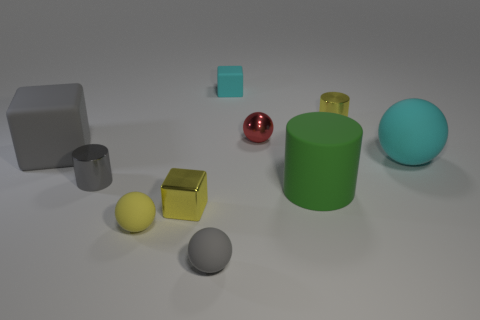The tiny yellow object that is right of the rubber cube behind the tiny metal object that is right of the small metallic ball is what shape?
Your answer should be very brief. Cylinder. There is a cyan thing that is on the left side of the large cyan matte object; is its shape the same as the small shiny object behind the red metal object?
Make the answer very short. No. What number of other things are made of the same material as the cyan cube?
Offer a very short reply. 5. The tiny gray object that is made of the same material as the small red sphere is what shape?
Offer a terse response. Cylinder. Does the green matte cylinder have the same size as the gray matte block?
Offer a very short reply. Yes. There is a metallic thing that is behind the small ball that is behind the yellow block; what size is it?
Provide a short and direct response. Small. There is a tiny rubber thing that is the same color as the large matte ball; what shape is it?
Give a very brief answer. Cube. What number of cylinders are either rubber things or small shiny objects?
Offer a very short reply. 3. There is a gray ball; does it have the same size as the cylinder behind the gray metallic cylinder?
Offer a terse response. Yes. Are there more tiny red spheres that are behind the small cyan matte object than large matte balls?
Make the answer very short. No. 